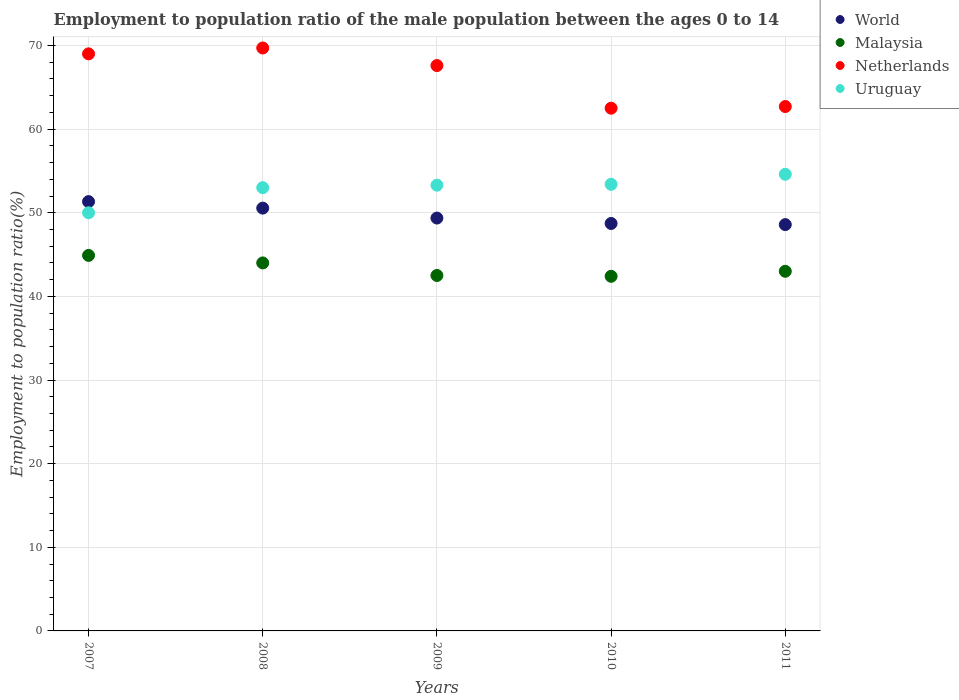How many different coloured dotlines are there?
Offer a very short reply. 4. What is the employment to population ratio in Malaysia in 2010?
Your answer should be compact. 42.4. Across all years, what is the maximum employment to population ratio in Malaysia?
Give a very brief answer. 44.9. Across all years, what is the minimum employment to population ratio in Malaysia?
Keep it short and to the point. 42.4. In which year was the employment to population ratio in World minimum?
Your response must be concise. 2011. What is the total employment to population ratio in Uruguay in the graph?
Ensure brevity in your answer.  264.3. What is the difference between the employment to population ratio in Uruguay in 2009 and that in 2010?
Offer a terse response. -0.1. What is the difference between the employment to population ratio in Netherlands in 2007 and the employment to population ratio in World in 2010?
Offer a terse response. 20.28. What is the average employment to population ratio in World per year?
Provide a succinct answer. 49.71. In the year 2009, what is the difference between the employment to population ratio in Uruguay and employment to population ratio in World?
Make the answer very short. 3.93. What is the ratio of the employment to population ratio in Malaysia in 2009 to that in 2011?
Provide a short and direct response. 0.99. Is the employment to population ratio in Netherlands in 2008 less than that in 2011?
Give a very brief answer. No. Is the difference between the employment to population ratio in Uruguay in 2010 and 2011 greater than the difference between the employment to population ratio in World in 2010 and 2011?
Your answer should be compact. No. What is the difference between the highest and the second highest employment to population ratio in World?
Offer a terse response. 0.78. What is the difference between the highest and the lowest employment to population ratio in Netherlands?
Your answer should be very brief. 7.2. In how many years, is the employment to population ratio in Malaysia greater than the average employment to population ratio in Malaysia taken over all years?
Your answer should be very brief. 2. Is the sum of the employment to population ratio in Uruguay in 2009 and 2011 greater than the maximum employment to population ratio in Malaysia across all years?
Offer a terse response. Yes. Is it the case that in every year, the sum of the employment to population ratio in World and employment to population ratio in Malaysia  is greater than the sum of employment to population ratio in Uruguay and employment to population ratio in Netherlands?
Your response must be concise. No. Is it the case that in every year, the sum of the employment to population ratio in Netherlands and employment to population ratio in Malaysia  is greater than the employment to population ratio in Uruguay?
Make the answer very short. Yes. Does the employment to population ratio in Netherlands monotonically increase over the years?
Ensure brevity in your answer.  No. What is the difference between two consecutive major ticks on the Y-axis?
Your answer should be very brief. 10. Are the values on the major ticks of Y-axis written in scientific E-notation?
Your response must be concise. No. Does the graph contain grids?
Provide a short and direct response. Yes. What is the title of the graph?
Provide a short and direct response. Employment to population ratio of the male population between the ages 0 to 14. What is the label or title of the Y-axis?
Your response must be concise. Employment to population ratio(%). What is the Employment to population ratio(%) in World in 2007?
Make the answer very short. 51.33. What is the Employment to population ratio(%) of Malaysia in 2007?
Ensure brevity in your answer.  44.9. What is the Employment to population ratio(%) of World in 2008?
Provide a short and direct response. 50.55. What is the Employment to population ratio(%) in Netherlands in 2008?
Your response must be concise. 69.7. What is the Employment to population ratio(%) in World in 2009?
Provide a short and direct response. 49.37. What is the Employment to population ratio(%) in Malaysia in 2009?
Offer a terse response. 42.5. What is the Employment to population ratio(%) in Netherlands in 2009?
Your answer should be compact. 67.6. What is the Employment to population ratio(%) in Uruguay in 2009?
Your answer should be very brief. 53.3. What is the Employment to population ratio(%) of World in 2010?
Provide a short and direct response. 48.72. What is the Employment to population ratio(%) of Malaysia in 2010?
Offer a terse response. 42.4. What is the Employment to population ratio(%) in Netherlands in 2010?
Your answer should be very brief. 62.5. What is the Employment to population ratio(%) in Uruguay in 2010?
Offer a terse response. 53.4. What is the Employment to population ratio(%) in World in 2011?
Your answer should be compact. 48.58. What is the Employment to population ratio(%) of Netherlands in 2011?
Offer a terse response. 62.7. What is the Employment to population ratio(%) of Uruguay in 2011?
Provide a short and direct response. 54.6. Across all years, what is the maximum Employment to population ratio(%) of World?
Offer a terse response. 51.33. Across all years, what is the maximum Employment to population ratio(%) in Malaysia?
Your response must be concise. 44.9. Across all years, what is the maximum Employment to population ratio(%) of Netherlands?
Keep it short and to the point. 69.7. Across all years, what is the maximum Employment to population ratio(%) in Uruguay?
Offer a terse response. 54.6. Across all years, what is the minimum Employment to population ratio(%) of World?
Offer a terse response. 48.58. Across all years, what is the minimum Employment to population ratio(%) in Malaysia?
Keep it short and to the point. 42.4. Across all years, what is the minimum Employment to population ratio(%) in Netherlands?
Offer a terse response. 62.5. Across all years, what is the minimum Employment to population ratio(%) of Uruguay?
Your response must be concise. 50. What is the total Employment to population ratio(%) in World in the graph?
Ensure brevity in your answer.  248.55. What is the total Employment to population ratio(%) in Malaysia in the graph?
Ensure brevity in your answer.  216.8. What is the total Employment to population ratio(%) of Netherlands in the graph?
Keep it short and to the point. 331.5. What is the total Employment to population ratio(%) in Uruguay in the graph?
Your response must be concise. 264.3. What is the difference between the Employment to population ratio(%) in World in 2007 and that in 2008?
Offer a very short reply. 0.78. What is the difference between the Employment to population ratio(%) in Malaysia in 2007 and that in 2008?
Offer a very short reply. 0.9. What is the difference between the Employment to population ratio(%) in Uruguay in 2007 and that in 2008?
Keep it short and to the point. -3. What is the difference between the Employment to population ratio(%) in World in 2007 and that in 2009?
Offer a terse response. 1.97. What is the difference between the Employment to population ratio(%) in Malaysia in 2007 and that in 2009?
Give a very brief answer. 2.4. What is the difference between the Employment to population ratio(%) in Netherlands in 2007 and that in 2009?
Your response must be concise. 1.4. What is the difference between the Employment to population ratio(%) of Uruguay in 2007 and that in 2009?
Give a very brief answer. -3.3. What is the difference between the Employment to population ratio(%) of World in 2007 and that in 2010?
Keep it short and to the point. 2.62. What is the difference between the Employment to population ratio(%) in World in 2007 and that in 2011?
Offer a terse response. 2.75. What is the difference between the Employment to population ratio(%) of Malaysia in 2007 and that in 2011?
Ensure brevity in your answer.  1.9. What is the difference between the Employment to population ratio(%) in Netherlands in 2007 and that in 2011?
Keep it short and to the point. 6.3. What is the difference between the Employment to population ratio(%) in World in 2008 and that in 2009?
Give a very brief answer. 1.19. What is the difference between the Employment to population ratio(%) of Malaysia in 2008 and that in 2009?
Offer a very short reply. 1.5. What is the difference between the Employment to population ratio(%) in World in 2008 and that in 2010?
Give a very brief answer. 1.84. What is the difference between the Employment to population ratio(%) in Uruguay in 2008 and that in 2010?
Your answer should be compact. -0.4. What is the difference between the Employment to population ratio(%) of World in 2008 and that in 2011?
Your answer should be compact. 1.97. What is the difference between the Employment to population ratio(%) in Malaysia in 2008 and that in 2011?
Give a very brief answer. 1. What is the difference between the Employment to population ratio(%) of Uruguay in 2008 and that in 2011?
Provide a succinct answer. -1.6. What is the difference between the Employment to population ratio(%) of World in 2009 and that in 2010?
Your response must be concise. 0.65. What is the difference between the Employment to population ratio(%) in Malaysia in 2009 and that in 2010?
Keep it short and to the point. 0.1. What is the difference between the Employment to population ratio(%) of Netherlands in 2009 and that in 2010?
Your answer should be compact. 5.1. What is the difference between the Employment to population ratio(%) of Uruguay in 2009 and that in 2010?
Give a very brief answer. -0.1. What is the difference between the Employment to population ratio(%) of World in 2009 and that in 2011?
Keep it short and to the point. 0.78. What is the difference between the Employment to population ratio(%) of Malaysia in 2009 and that in 2011?
Offer a terse response. -0.5. What is the difference between the Employment to population ratio(%) in Uruguay in 2009 and that in 2011?
Give a very brief answer. -1.3. What is the difference between the Employment to population ratio(%) in World in 2010 and that in 2011?
Keep it short and to the point. 0.14. What is the difference between the Employment to population ratio(%) in Malaysia in 2010 and that in 2011?
Ensure brevity in your answer.  -0.6. What is the difference between the Employment to population ratio(%) in Netherlands in 2010 and that in 2011?
Keep it short and to the point. -0.2. What is the difference between the Employment to population ratio(%) in World in 2007 and the Employment to population ratio(%) in Malaysia in 2008?
Offer a terse response. 7.33. What is the difference between the Employment to population ratio(%) in World in 2007 and the Employment to population ratio(%) in Netherlands in 2008?
Keep it short and to the point. -18.37. What is the difference between the Employment to population ratio(%) in World in 2007 and the Employment to population ratio(%) in Uruguay in 2008?
Ensure brevity in your answer.  -1.67. What is the difference between the Employment to population ratio(%) of Malaysia in 2007 and the Employment to population ratio(%) of Netherlands in 2008?
Offer a terse response. -24.8. What is the difference between the Employment to population ratio(%) in Malaysia in 2007 and the Employment to population ratio(%) in Uruguay in 2008?
Offer a very short reply. -8.1. What is the difference between the Employment to population ratio(%) of World in 2007 and the Employment to population ratio(%) of Malaysia in 2009?
Offer a terse response. 8.83. What is the difference between the Employment to population ratio(%) in World in 2007 and the Employment to population ratio(%) in Netherlands in 2009?
Provide a short and direct response. -16.27. What is the difference between the Employment to population ratio(%) in World in 2007 and the Employment to population ratio(%) in Uruguay in 2009?
Keep it short and to the point. -1.97. What is the difference between the Employment to population ratio(%) in Malaysia in 2007 and the Employment to population ratio(%) in Netherlands in 2009?
Offer a very short reply. -22.7. What is the difference between the Employment to population ratio(%) in Netherlands in 2007 and the Employment to population ratio(%) in Uruguay in 2009?
Your answer should be very brief. 15.7. What is the difference between the Employment to population ratio(%) in World in 2007 and the Employment to population ratio(%) in Malaysia in 2010?
Keep it short and to the point. 8.93. What is the difference between the Employment to population ratio(%) in World in 2007 and the Employment to population ratio(%) in Netherlands in 2010?
Provide a short and direct response. -11.17. What is the difference between the Employment to population ratio(%) in World in 2007 and the Employment to population ratio(%) in Uruguay in 2010?
Offer a terse response. -2.07. What is the difference between the Employment to population ratio(%) of Malaysia in 2007 and the Employment to population ratio(%) of Netherlands in 2010?
Keep it short and to the point. -17.6. What is the difference between the Employment to population ratio(%) in Netherlands in 2007 and the Employment to population ratio(%) in Uruguay in 2010?
Your answer should be very brief. 15.6. What is the difference between the Employment to population ratio(%) in World in 2007 and the Employment to population ratio(%) in Malaysia in 2011?
Keep it short and to the point. 8.33. What is the difference between the Employment to population ratio(%) in World in 2007 and the Employment to population ratio(%) in Netherlands in 2011?
Make the answer very short. -11.37. What is the difference between the Employment to population ratio(%) of World in 2007 and the Employment to population ratio(%) of Uruguay in 2011?
Offer a terse response. -3.27. What is the difference between the Employment to population ratio(%) of Malaysia in 2007 and the Employment to population ratio(%) of Netherlands in 2011?
Offer a very short reply. -17.8. What is the difference between the Employment to population ratio(%) of World in 2008 and the Employment to population ratio(%) of Malaysia in 2009?
Give a very brief answer. 8.05. What is the difference between the Employment to population ratio(%) of World in 2008 and the Employment to population ratio(%) of Netherlands in 2009?
Give a very brief answer. -17.05. What is the difference between the Employment to population ratio(%) in World in 2008 and the Employment to population ratio(%) in Uruguay in 2009?
Give a very brief answer. -2.75. What is the difference between the Employment to population ratio(%) in Malaysia in 2008 and the Employment to population ratio(%) in Netherlands in 2009?
Ensure brevity in your answer.  -23.6. What is the difference between the Employment to population ratio(%) in World in 2008 and the Employment to population ratio(%) in Malaysia in 2010?
Your answer should be compact. 8.15. What is the difference between the Employment to population ratio(%) of World in 2008 and the Employment to population ratio(%) of Netherlands in 2010?
Keep it short and to the point. -11.95. What is the difference between the Employment to population ratio(%) in World in 2008 and the Employment to population ratio(%) in Uruguay in 2010?
Ensure brevity in your answer.  -2.85. What is the difference between the Employment to population ratio(%) of Malaysia in 2008 and the Employment to population ratio(%) of Netherlands in 2010?
Offer a very short reply. -18.5. What is the difference between the Employment to population ratio(%) of World in 2008 and the Employment to population ratio(%) of Malaysia in 2011?
Keep it short and to the point. 7.55. What is the difference between the Employment to population ratio(%) in World in 2008 and the Employment to population ratio(%) in Netherlands in 2011?
Your response must be concise. -12.15. What is the difference between the Employment to population ratio(%) of World in 2008 and the Employment to population ratio(%) of Uruguay in 2011?
Your response must be concise. -4.05. What is the difference between the Employment to population ratio(%) of Malaysia in 2008 and the Employment to population ratio(%) of Netherlands in 2011?
Provide a short and direct response. -18.7. What is the difference between the Employment to population ratio(%) of Malaysia in 2008 and the Employment to population ratio(%) of Uruguay in 2011?
Provide a short and direct response. -10.6. What is the difference between the Employment to population ratio(%) in World in 2009 and the Employment to population ratio(%) in Malaysia in 2010?
Offer a very short reply. 6.97. What is the difference between the Employment to population ratio(%) of World in 2009 and the Employment to population ratio(%) of Netherlands in 2010?
Your response must be concise. -13.13. What is the difference between the Employment to population ratio(%) of World in 2009 and the Employment to population ratio(%) of Uruguay in 2010?
Offer a very short reply. -4.03. What is the difference between the Employment to population ratio(%) in Malaysia in 2009 and the Employment to population ratio(%) in Netherlands in 2010?
Provide a succinct answer. -20. What is the difference between the Employment to population ratio(%) in World in 2009 and the Employment to population ratio(%) in Malaysia in 2011?
Ensure brevity in your answer.  6.37. What is the difference between the Employment to population ratio(%) in World in 2009 and the Employment to population ratio(%) in Netherlands in 2011?
Ensure brevity in your answer.  -13.33. What is the difference between the Employment to population ratio(%) in World in 2009 and the Employment to population ratio(%) in Uruguay in 2011?
Give a very brief answer. -5.23. What is the difference between the Employment to population ratio(%) of Malaysia in 2009 and the Employment to population ratio(%) of Netherlands in 2011?
Provide a succinct answer. -20.2. What is the difference between the Employment to population ratio(%) of World in 2010 and the Employment to population ratio(%) of Malaysia in 2011?
Your response must be concise. 5.72. What is the difference between the Employment to population ratio(%) of World in 2010 and the Employment to population ratio(%) of Netherlands in 2011?
Give a very brief answer. -13.98. What is the difference between the Employment to population ratio(%) of World in 2010 and the Employment to population ratio(%) of Uruguay in 2011?
Provide a short and direct response. -5.88. What is the difference between the Employment to population ratio(%) of Malaysia in 2010 and the Employment to population ratio(%) of Netherlands in 2011?
Offer a very short reply. -20.3. What is the difference between the Employment to population ratio(%) in Malaysia in 2010 and the Employment to population ratio(%) in Uruguay in 2011?
Give a very brief answer. -12.2. What is the difference between the Employment to population ratio(%) in Netherlands in 2010 and the Employment to population ratio(%) in Uruguay in 2011?
Your response must be concise. 7.9. What is the average Employment to population ratio(%) of World per year?
Keep it short and to the point. 49.71. What is the average Employment to population ratio(%) of Malaysia per year?
Your answer should be very brief. 43.36. What is the average Employment to population ratio(%) in Netherlands per year?
Provide a succinct answer. 66.3. What is the average Employment to population ratio(%) in Uruguay per year?
Offer a terse response. 52.86. In the year 2007, what is the difference between the Employment to population ratio(%) in World and Employment to population ratio(%) in Malaysia?
Make the answer very short. 6.43. In the year 2007, what is the difference between the Employment to population ratio(%) in World and Employment to population ratio(%) in Netherlands?
Offer a terse response. -17.67. In the year 2007, what is the difference between the Employment to population ratio(%) in World and Employment to population ratio(%) in Uruguay?
Your response must be concise. 1.33. In the year 2007, what is the difference between the Employment to population ratio(%) of Malaysia and Employment to population ratio(%) of Netherlands?
Provide a short and direct response. -24.1. In the year 2007, what is the difference between the Employment to population ratio(%) of Malaysia and Employment to population ratio(%) of Uruguay?
Offer a very short reply. -5.1. In the year 2008, what is the difference between the Employment to population ratio(%) of World and Employment to population ratio(%) of Malaysia?
Provide a short and direct response. 6.55. In the year 2008, what is the difference between the Employment to population ratio(%) in World and Employment to population ratio(%) in Netherlands?
Your response must be concise. -19.15. In the year 2008, what is the difference between the Employment to population ratio(%) of World and Employment to population ratio(%) of Uruguay?
Provide a succinct answer. -2.45. In the year 2008, what is the difference between the Employment to population ratio(%) in Malaysia and Employment to population ratio(%) in Netherlands?
Your answer should be compact. -25.7. In the year 2008, what is the difference between the Employment to population ratio(%) of Malaysia and Employment to population ratio(%) of Uruguay?
Keep it short and to the point. -9. In the year 2008, what is the difference between the Employment to population ratio(%) of Netherlands and Employment to population ratio(%) of Uruguay?
Your response must be concise. 16.7. In the year 2009, what is the difference between the Employment to population ratio(%) in World and Employment to population ratio(%) in Malaysia?
Provide a short and direct response. 6.87. In the year 2009, what is the difference between the Employment to population ratio(%) in World and Employment to population ratio(%) in Netherlands?
Make the answer very short. -18.23. In the year 2009, what is the difference between the Employment to population ratio(%) in World and Employment to population ratio(%) in Uruguay?
Offer a terse response. -3.93. In the year 2009, what is the difference between the Employment to population ratio(%) of Malaysia and Employment to population ratio(%) of Netherlands?
Provide a short and direct response. -25.1. In the year 2009, what is the difference between the Employment to population ratio(%) of Netherlands and Employment to population ratio(%) of Uruguay?
Offer a terse response. 14.3. In the year 2010, what is the difference between the Employment to population ratio(%) in World and Employment to population ratio(%) in Malaysia?
Your response must be concise. 6.32. In the year 2010, what is the difference between the Employment to population ratio(%) in World and Employment to population ratio(%) in Netherlands?
Give a very brief answer. -13.78. In the year 2010, what is the difference between the Employment to population ratio(%) of World and Employment to population ratio(%) of Uruguay?
Provide a succinct answer. -4.68. In the year 2010, what is the difference between the Employment to population ratio(%) of Malaysia and Employment to population ratio(%) of Netherlands?
Make the answer very short. -20.1. In the year 2010, what is the difference between the Employment to population ratio(%) of Netherlands and Employment to population ratio(%) of Uruguay?
Make the answer very short. 9.1. In the year 2011, what is the difference between the Employment to population ratio(%) in World and Employment to population ratio(%) in Malaysia?
Provide a succinct answer. 5.58. In the year 2011, what is the difference between the Employment to population ratio(%) of World and Employment to population ratio(%) of Netherlands?
Offer a very short reply. -14.12. In the year 2011, what is the difference between the Employment to population ratio(%) in World and Employment to population ratio(%) in Uruguay?
Keep it short and to the point. -6.02. In the year 2011, what is the difference between the Employment to population ratio(%) of Malaysia and Employment to population ratio(%) of Netherlands?
Ensure brevity in your answer.  -19.7. In the year 2011, what is the difference between the Employment to population ratio(%) in Netherlands and Employment to population ratio(%) in Uruguay?
Your answer should be very brief. 8.1. What is the ratio of the Employment to population ratio(%) of World in 2007 to that in 2008?
Keep it short and to the point. 1.02. What is the ratio of the Employment to population ratio(%) in Malaysia in 2007 to that in 2008?
Your response must be concise. 1.02. What is the ratio of the Employment to population ratio(%) of Uruguay in 2007 to that in 2008?
Your response must be concise. 0.94. What is the ratio of the Employment to population ratio(%) in World in 2007 to that in 2009?
Offer a very short reply. 1.04. What is the ratio of the Employment to population ratio(%) of Malaysia in 2007 to that in 2009?
Your response must be concise. 1.06. What is the ratio of the Employment to population ratio(%) in Netherlands in 2007 to that in 2009?
Give a very brief answer. 1.02. What is the ratio of the Employment to population ratio(%) of Uruguay in 2007 to that in 2009?
Your answer should be compact. 0.94. What is the ratio of the Employment to population ratio(%) in World in 2007 to that in 2010?
Provide a short and direct response. 1.05. What is the ratio of the Employment to population ratio(%) of Malaysia in 2007 to that in 2010?
Give a very brief answer. 1.06. What is the ratio of the Employment to population ratio(%) of Netherlands in 2007 to that in 2010?
Your answer should be compact. 1.1. What is the ratio of the Employment to population ratio(%) in Uruguay in 2007 to that in 2010?
Your answer should be compact. 0.94. What is the ratio of the Employment to population ratio(%) in World in 2007 to that in 2011?
Your answer should be very brief. 1.06. What is the ratio of the Employment to population ratio(%) of Malaysia in 2007 to that in 2011?
Give a very brief answer. 1.04. What is the ratio of the Employment to population ratio(%) of Netherlands in 2007 to that in 2011?
Ensure brevity in your answer.  1.1. What is the ratio of the Employment to population ratio(%) in Uruguay in 2007 to that in 2011?
Offer a terse response. 0.92. What is the ratio of the Employment to population ratio(%) of World in 2008 to that in 2009?
Your answer should be very brief. 1.02. What is the ratio of the Employment to population ratio(%) in Malaysia in 2008 to that in 2009?
Your answer should be compact. 1.04. What is the ratio of the Employment to population ratio(%) of Netherlands in 2008 to that in 2009?
Provide a short and direct response. 1.03. What is the ratio of the Employment to population ratio(%) in Uruguay in 2008 to that in 2009?
Ensure brevity in your answer.  0.99. What is the ratio of the Employment to population ratio(%) of World in 2008 to that in 2010?
Provide a succinct answer. 1.04. What is the ratio of the Employment to population ratio(%) in Malaysia in 2008 to that in 2010?
Your response must be concise. 1.04. What is the ratio of the Employment to population ratio(%) of Netherlands in 2008 to that in 2010?
Give a very brief answer. 1.12. What is the ratio of the Employment to population ratio(%) of World in 2008 to that in 2011?
Keep it short and to the point. 1.04. What is the ratio of the Employment to population ratio(%) in Malaysia in 2008 to that in 2011?
Offer a very short reply. 1.02. What is the ratio of the Employment to population ratio(%) of Netherlands in 2008 to that in 2011?
Make the answer very short. 1.11. What is the ratio of the Employment to population ratio(%) in Uruguay in 2008 to that in 2011?
Offer a very short reply. 0.97. What is the ratio of the Employment to population ratio(%) in World in 2009 to that in 2010?
Offer a terse response. 1.01. What is the ratio of the Employment to population ratio(%) in Netherlands in 2009 to that in 2010?
Your answer should be compact. 1.08. What is the ratio of the Employment to population ratio(%) in Uruguay in 2009 to that in 2010?
Make the answer very short. 1. What is the ratio of the Employment to population ratio(%) of World in 2009 to that in 2011?
Offer a terse response. 1.02. What is the ratio of the Employment to population ratio(%) in Malaysia in 2009 to that in 2011?
Your answer should be compact. 0.99. What is the ratio of the Employment to population ratio(%) of Netherlands in 2009 to that in 2011?
Your answer should be compact. 1.08. What is the ratio of the Employment to population ratio(%) of Uruguay in 2009 to that in 2011?
Your answer should be compact. 0.98. What is the ratio of the Employment to population ratio(%) in World in 2010 to that in 2011?
Give a very brief answer. 1. What is the ratio of the Employment to population ratio(%) in Malaysia in 2010 to that in 2011?
Your response must be concise. 0.99. What is the ratio of the Employment to population ratio(%) of Netherlands in 2010 to that in 2011?
Provide a short and direct response. 1. What is the difference between the highest and the second highest Employment to population ratio(%) in World?
Your answer should be very brief. 0.78. What is the difference between the highest and the second highest Employment to population ratio(%) of Malaysia?
Your answer should be very brief. 0.9. What is the difference between the highest and the lowest Employment to population ratio(%) of World?
Make the answer very short. 2.75. What is the difference between the highest and the lowest Employment to population ratio(%) in Uruguay?
Your answer should be compact. 4.6. 